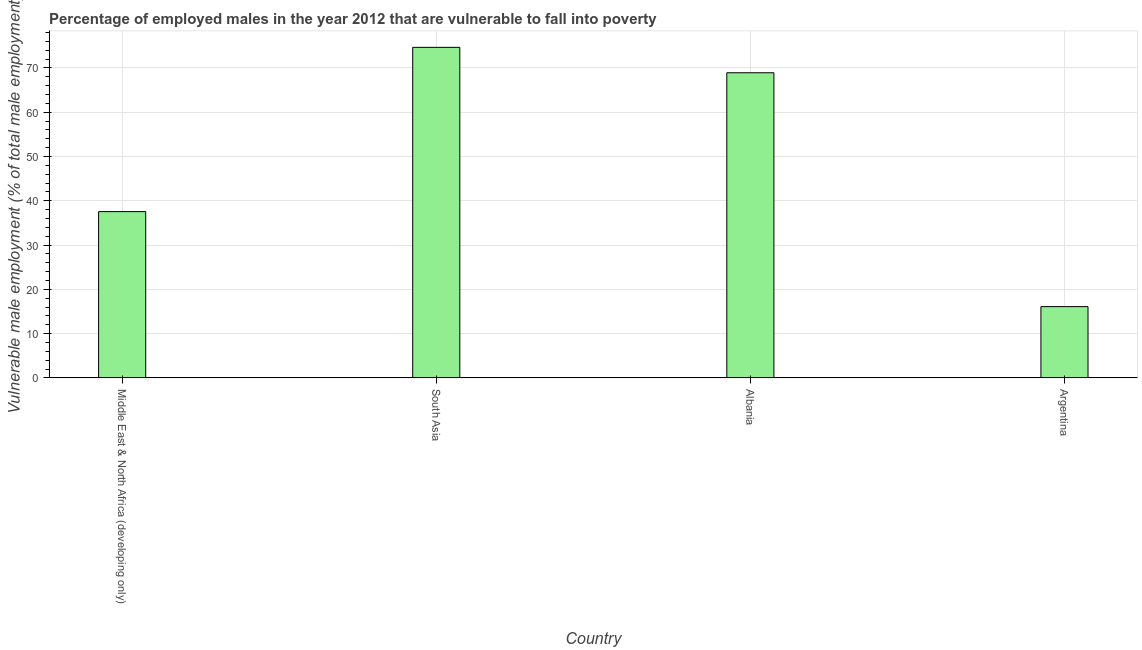Does the graph contain any zero values?
Your answer should be very brief. No. What is the title of the graph?
Your response must be concise. Percentage of employed males in the year 2012 that are vulnerable to fall into poverty. What is the label or title of the X-axis?
Offer a terse response. Country. What is the label or title of the Y-axis?
Give a very brief answer. Vulnerable male employment (% of total male employment). What is the percentage of employed males who are vulnerable to fall into poverty in South Asia?
Your answer should be compact. 74.64. Across all countries, what is the maximum percentage of employed males who are vulnerable to fall into poverty?
Your response must be concise. 74.64. Across all countries, what is the minimum percentage of employed males who are vulnerable to fall into poverty?
Provide a short and direct response. 16.1. In which country was the percentage of employed males who are vulnerable to fall into poverty minimum?
Make the answer very short. Argentina. What is the sum of the percentage of employed males who are vulnerable to fall into poverty?
Offer a very short reply. 197.19. What is the difference between the percentage of employed males who are vulnerable to fall into poverty in Argentina and South Asia?
Ensure brevity in your answer.  -58.54. What is the average percentage of employed males who are vulnerable to fall into poverty per country?
Provide a succinct answer. 49.3. What is the median percentage of employed males who are vulnerable to fall into poverty?
Your answer should be compact. 53.22. What is the ratio of the percentage of employed males who are vulnerable to fall into poverty in Middle East & North Africa (developing only) to that in South Asia?
Give a very brief answer. 0.5. What is the difference between the highest and the second highest percentage of employed males who are vulnerable to fall into poverty?
Your response must be concise. 5.74. Is the sum of the percentage of employed males who are vulnerable to fall into poverty in Middle East & North Africa (developing only) and South Asia greater than the maximum percentage of employed males who are vulnerable to fall into poverty across all countries?
Your answer should be very brief. Yes. What is the difference between the highest and the lowest percentage of employed males who are vulnerable to fall into poverty?
Your answer should be compact. 58.54. How many bars are there?
Your response must be concise. 4. Are all the bars in the graph horizontal?
Offer a very short reply. No. How many countries are there in the graph?
Your answer should be very brief. 4. What is the difference between two consecutive major ticks on the Y-axis?
Provide a succinct answer. 10. Are the values on the major ticks of Y-axis written in scientific E-notation?
Ensure brevity in your answer.  No. What is the Vulnerable male employment (% of total male employment) of Middle East & North Africa (developing only)?
Your answer should be compact. 37.55. What is the Vulnerable male employment (% of total male employment) of South Asia?
Give a very brief answer. 74.64. What is the Vulnerable male employment (% of total male employment) of Albania?
Offer a terse response. 68.9. What is the Vulnerable male employment (% of total male employment) of Argentina?
Your answer should be very brief. 16.1. What is the difference between the Vulnerable male employment (% of total male employment) in Middle East & North Africa (developing only) and South Asia?
Offer a very short reply. -37.09. What is the difference between the Vulnerable male employment (% of total male employment) in Middle East & North Africa (developing only) and Albania?
Provide a short and direct response. -31.35. What is the difference between the Vulnerable male employment (% of total male employment) in Middle East & North Africa (developing only) and Argentina?
Make the answer very short. 21.45. What is the difference between the Vulnerable male employment (% of total male employment) in South Asia and Albania?
Ensure brevity in your answer.  5.74. What is the difference between the Vulnerable male employment (% of total male employment) in South Asia and Argentina?
Provide a short and direct response. 58.54. What is the difference between the Vulnerable male employment (% of total male employment) in Albania and Argentina?
Offer a very short reply. 52.8. What is the ratio of the Vulnerable male employment (% of total male employment) in Middle East & North Africa (developing only) to that in South Asia?
Give a very brief answer. 0.5. What is the ratio of the Vulnerable male employment (% of total male employment) in Middle East & North Africa (developing only) to that in Albania?
Provide a short and direct response. 0.55. What is the ratio of the Vulnerable male employment (% of total male employment) in Middle East & North Africa (developing only) to that in Argentina?
Offer a terse response. 2.33. What is the ratio of the Vulnerable male employment (% of total male employment) in South Asia to that in Albania?
Offer a very short reply. 1.08. What is the ratio of the Vulnerable male employment (% of total male employment) in South Asia to that in Argentina?
Keep it short and to the point. 4.64. What is the ratio of the Vulnerable male employment (% of total male employment) in Albania to that in Argentina?
Give a very brief answer. 4.28. 